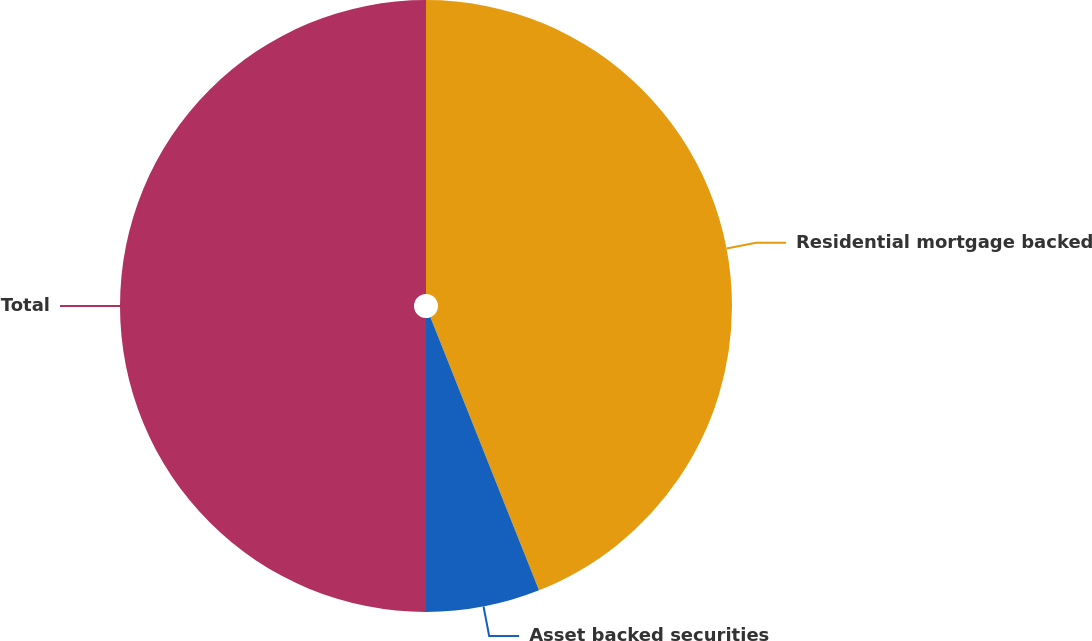Convert chart. <chart><loc_0><loc_0><loc_500><loc_500><pie_chart><fcel>Residential mortgage backed<fcel>Asset backed securities<fcel>Total<nl><fcel>43.98%<fcel>6.02%<fcel>50.0%<nl></chart> 